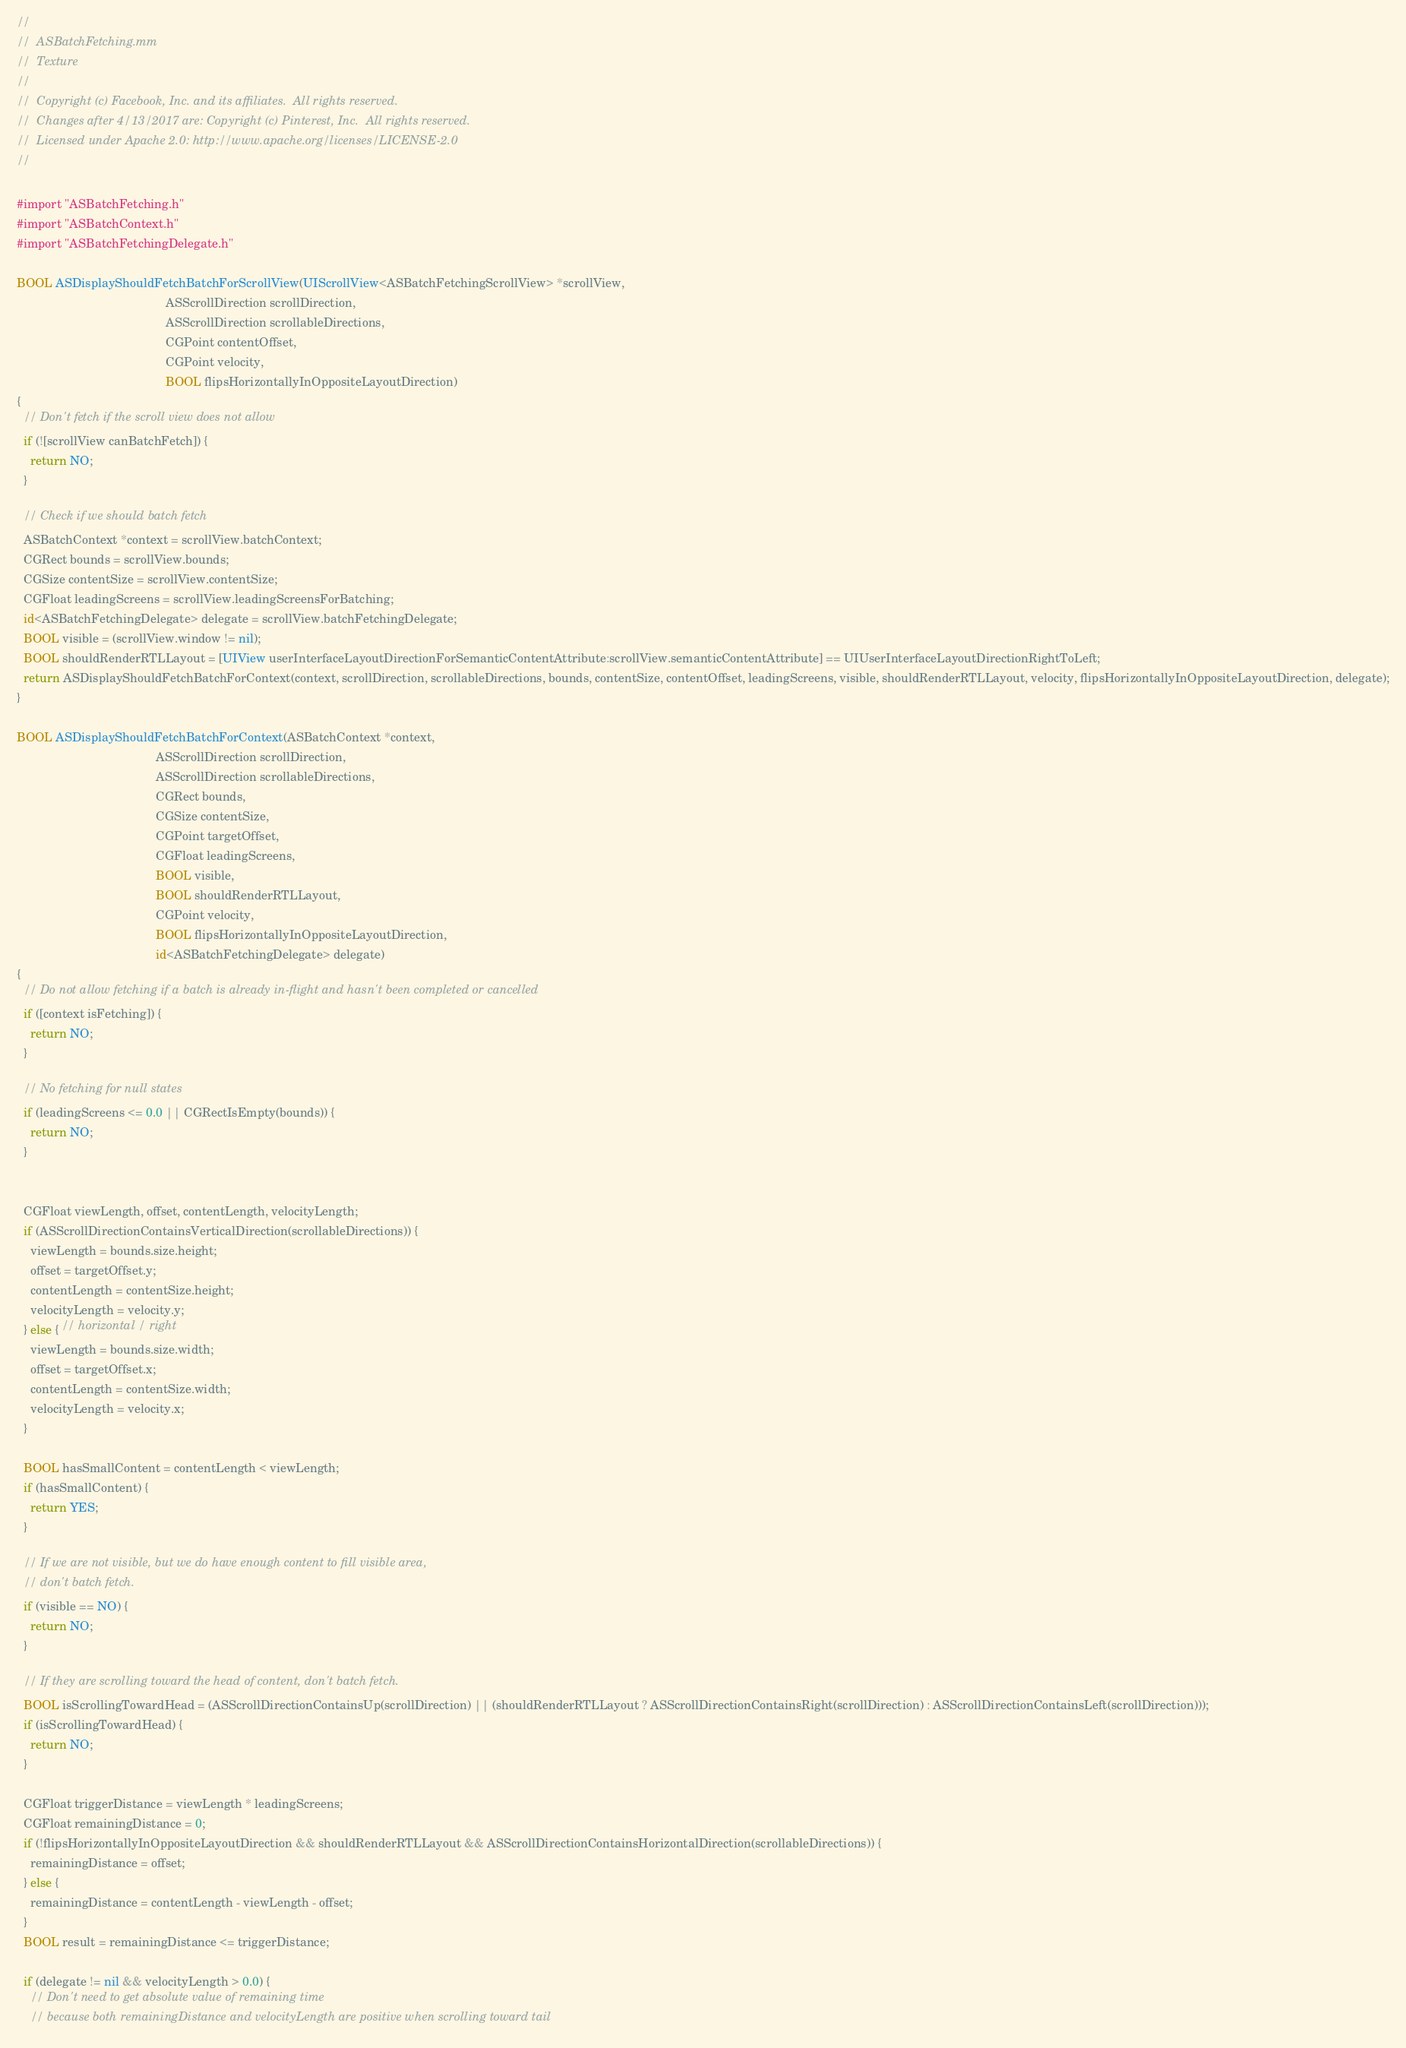<code> <loc_0><loc_0><loc_500><loc_500><_ObjectiveC_>//
//  ASBatchFetching.mm
//  Texture
//
//  Copyright (c) Facebook, Inc. and its affiliates.  All rights reserved.
//  Changes after 4/13/2017 are: Copyright (c) Pinterest, Inc.  All rights reserved.
//  Licensed under Apache 2.0: http://www.apache.org/licenses/LICENSE-2.0
//

#import "ASBatchFetching.h"
#import "ASBatchContext.h"
#import "ASBatchFetchingDelegate.h"

BOOL ASDisplayShouldFetchBatchForScrollView(UIScrollView<ASBatchFetchingScrollView> *scrollView,
                                            ASScrollDirection scrollDirection,
                                            ASScrollDirection scrollableDirections,
                                            CGPoint contentOffset,
                                            CGPoint velocity,
                                            BOOL flipsHorizontallyInOppositeLayoutDirection)
{
  // Don't fetch if the scroll view does not allow
  if (![scrollView canBatchFetch]) {
    return NO;
  }
  
  // Check if we should batch fetch
  ASBatchContext *context = scrollView.batchContext;
  CGRect bounds = scrollView.bounds;
  CGSize contentSize = scrollView.contentSize;
  CGFloat leadingScreens = scrollView.leadingScreensForBatching;
  id<ASBatchFetchingDelegate> delegate = scrollView.batchFetchingDelegate;
  BOOL visible = (scrollView.window != nil);
  BOOL shouldRenderRTLLayout = [UIView userInterfaceLayoutDirectionForSemanticContentAttribute:scrollView.semanticContentAttribute] == UIUserInterfaceLayoutDirectionRightToLeft;
  return ASDisplayShouldFetchBatchForContext(context, scrollDirection, scrollableDirections, bounds, contentSize, contentOffset, leadingScreens, visible, shouldRenderRTLLayout, velocity, flipsHorizontallyInOppositeLayoutDirection, delegate);
}

BOOL ASDisplayShouldFetchBatchForContext(ASBatchContext *context,
                                         ASScrollDirection scrollDirection,
                                         ASScrollDirection scrollableDirections,
                                         CGRect bounds,
                                         CGSize contentSize,
                                         CGPoint targetOffset,
                                         CGFloat leadingScreens,
                                         BOOL visible,
                                         BOOL shouldRenderRTLLayout,
                                         CGPoint velocity,
                                         BOOL flipsHorizontallyInOppositeLayoutDirection,
                                         id<ASBatchFetchingDelegate> delegate)
{
  // Do not allow fetching if a batch is already in-flight and hasn't been completed or cancelled
  if ([context isFetching]) {
    return NO;
  }

  // No fetching for null states
  if (leadingScreens <= 0.0 || CGRectIsEmpty(bounds)) {
    return NO;
  }


  CGFloat viewLength, offset, contentLength, velocityLength;
  if (ASScrollDirectionContainsVerticalDirection(scrollableDirections)) {
    viewLength = bounds.size.height;
    offset = targetOffset.y;
    contentLength = contentSize.height;
    velocityLength = velocity.y;
  } else { // horizontal / right
    viewLength = bounds.size.width;
    offset = targetOffset.x;
    contentLength = contentSize.width;
    velocityLength = velocity.x;
  }

  BOOL hasSmallContent = contentLength < viewLength;
  if (hasSmallContent) {
    return YES;
  }

  // If we are not visible, but we do have enough content to fill visible area,
  // don't batch fetch.
  if (visible == NO) {
    return NO;
  }

  // If they are scrolling toward the head of content, don't batch fetch.
  BOOL isScrollingTowardHead = (ASScrollDirectionContainsUp(scrollDirection) || (shouldRenderRTLLayout ? ASScrollDirectionContainsRight(scrollDirection) : ASScrollDirectionContainsLeft(scrollDirection)));
  if (isScrollingTowardHead) {
    return NO;
  }

  CGFloat triggerDistance = viewLength * leadingScreens;
  CGFloat remainingDistance = 0;
  if (!flipsHorizontallyInOppositeLayoutDirection && shouldRenderRTLLayout && ASScrollDirectionContainsHorizontalDirection(scrollableDirections)) {
    remainingDistance = offset;
  } else {
    remainingDistance = contentLength - viewLength - offset;
  }
  BOOL result = remainingDistance <= triggerDistance;

  if (delegate != nil && velocityLength > 0.0) {
    // Don't need to get absolute value of remaining time
    // because both remainingDistance and velocityLength are positive when scrolling toward tail</code> 